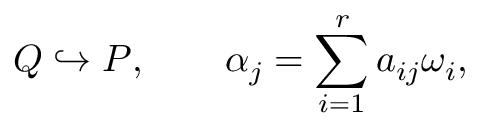Convert formula to latex. <formula><loc_0><loc_0><loc_500><loc_500>Q \hookrightarrow P , \quad \alpha _ { j } = \sum _ { i = 1 } ^ { r } a _ { i j } \omega _ { i } ,</formula> 